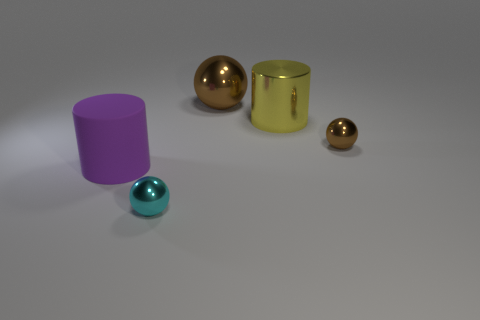How many cyan metallic spheres are right of the big metal cylinder?
Your answer should be compact. 0. There is a small object that is right of the large brown sphere; is its color the same as the big rubber cylinder?
Your answer should be very brief. No. How many gray objects are either small metal cubes or big cylinders?
Offer a very short reply. 0. The cylinder to the right of the tiny ball on the left side of the big metallic ball is what color?
Give a very brief answer. Yellow. What material is the tiny ball that is the same color as the large metal sphere?
Provide a succinct answer. Metal. There is a shiny sphere that is in front of the purple thing; what is its color?
Ensure brevity in your answer.  Cyan. There is a metallic object that is in front of the purple matte cylinder; does it have the same size as the purple rubber thing?
Offer a terse response. No. What is the size of the metallic object that is the same color as the big metallic sphere?
Your response must be concise. Small. Is there a purple rubber thing that has the same size as the cyan metallic object?
Provide a succinct answer. No. There is a object that is in front of the purple cylinder; is its color the same as the tiny metal thing on the right side of the big yellow cylinder?
Provide a short and direct response. No. 